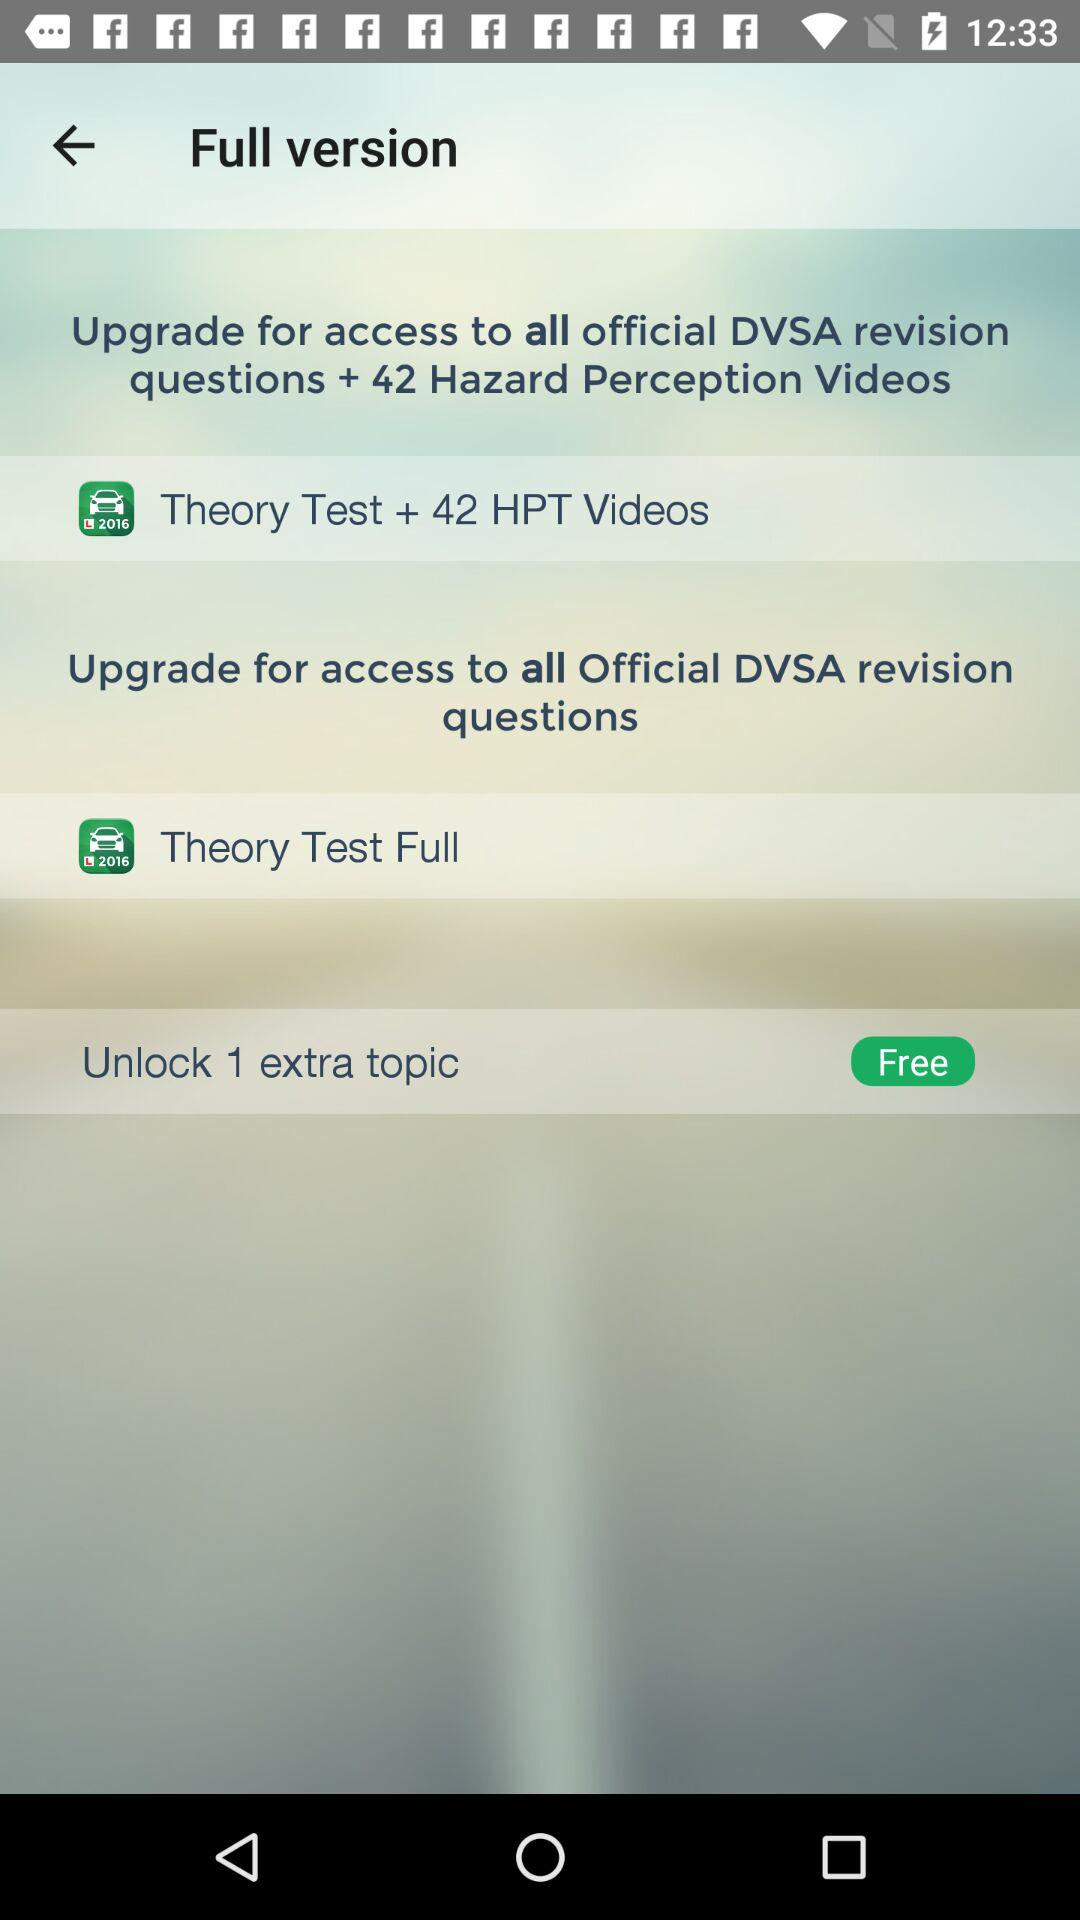How many more topics can I unlock by upgrading to the full version?
Answer the question using a single word or phrase. 1 